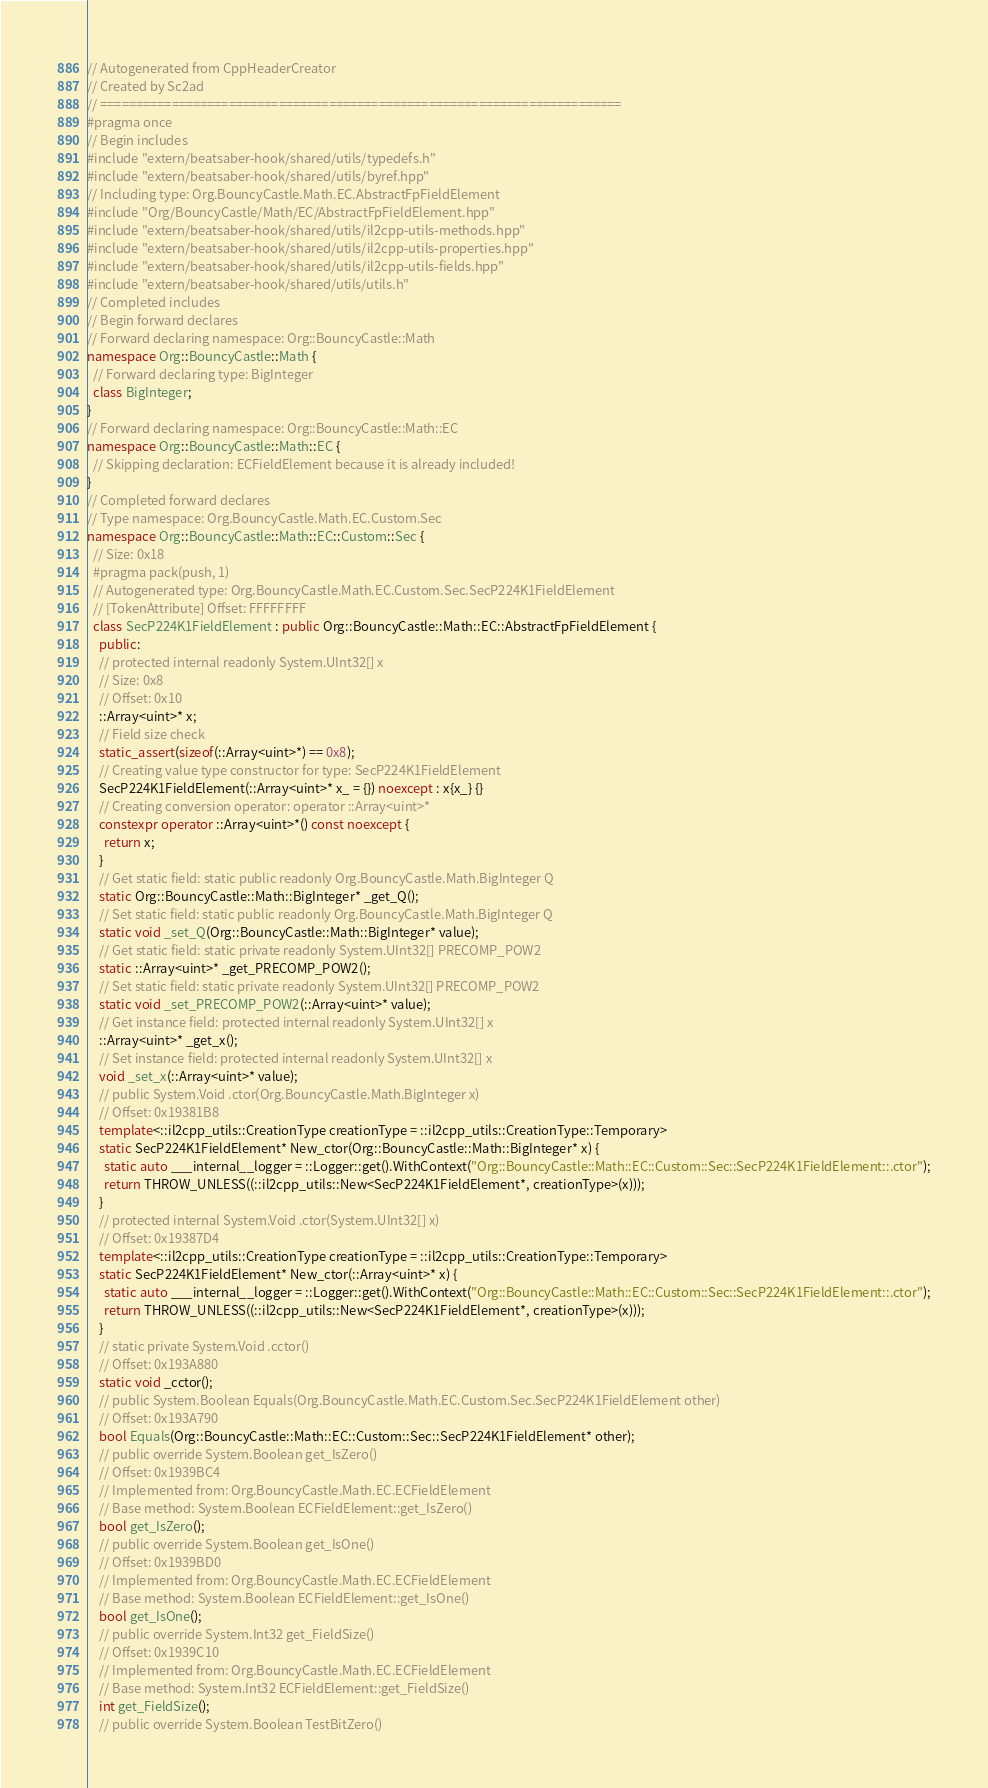<code> <loc_0><loc_0><loc_500><loc_500><_C++_>// Autogenerated from CppHeaderCreator
// Created by Sc2ad
// =========================================================================
#pragma once
// Begin includes
#include "extern/beatsaber-hook/shared/utils/typedefs.h"
#include "extern/beatsaber-hook/shared/utils/byref.hpp"
// Including type: Org.BouncyCastle.Math.EC.AbstractFpFieldElement
#include "Org/BouncyCastle/Math/EC/AbstractFpFieldElement.hpp"
#include "extern/beatsaber-hook/shared/utils/il2cpp-utils-methods.hpp"
#include "extern/beatsaber-hook/shared/utils/il2cpp-utils-properties.hpp"
#include "extern/beatsaber-hook/shared/utils/il2cpp-utils-fields.hpp"
#include "extern/beatsaber-hook/shared/utils/utils.h"
// Completed includes
// Begin forward declares
// Forward declaring namespace: Org::BouncyCastle::Math
namespace Org::BouncyCastle::Math {
  // Forward declaring type: BigInteger
  class BigInteger;
}
// Forward declaring namespace: Org::BouncyCastle::Math::EC
namespace Org::BouncyCastle::Math::EC {
  // Skipping declaration: ECFieldElement because it is already included!
}
// Completed forward declares
// Type namespace: Org.BouncyCastle.Math.EC.Custom.Sec
namespace Org::BouncyCastle::Math::EC::Custom::Sec {
  // Size: 0x18
  #pragma pack(push, 1)
  // Autogenerated type: Org.BouncyCastle.Math.EC.Custom.Sec.SecP224K1FieldElement
  // [TokenAttribute] Offset: FFFFFFFF
  class SecP224K1FieldElement : public Org::BouncyCastle::Math::EC::AbstractFpFieldElement {
    public:
    // protected internal readonly System.UInt32[] x
    // Size: 0x8
    // Offset: 0x10
    ::Array<uint>* x;
    // Field size check
    static_assert(sizeof(::Array<uint>*) == 0x8);
    // Creating value type constructor for type: SecP224K1FieldElement
    SecP224K1FieldElement(::Array<uint>* x_ = {}) noexcept : x{x_} {}
    // Creating conversion operator: operator ::Array<uint>*
    constexpr operator ::Array<uint>*() const noexcept {
      return x;
    }
    // Get static field: static public readonly Org.BouncyCastle.Math.BigInteger Q
    static Org::BouncyCastle::Math::BigInteger* _get_Q();
    // Set static field: static public readonly Org.BouncyCastle.Math.BigInteger Q
    static void _set_Q(Org::BouncyCastle::Math::BigInteger* value);
    // Get static field: static private readonly System.UInt32[] PRECOMP_POW2
    static ::Array<uint>* _get_PRECOMP_POW2();
    // Set static field: static private readonly System.UInt32[] PRECOMP_POW2
    static void _set_PRECOMP_POW2(::Array<uint>* value);
    // Get instance field: protected internal readonly System.UInt32[] x
    ::Array<uint>* _get_x();
    // Set instance field: protected internal readonly System.UInt32[] x
    void _set_x(::Array<uint>* value);
    // public System.Void .ctor(Org.BouncyCastle.Math.BigInteger x)
    // Offset: 0x19381B8
    template<::il2cpp_utils::CreationType creationType = ::il2cpp_utils::CreationType::Temporary>
    static SecP224K1FieldElement* New_ctor(Org::BouncyCastle::Math::BigInteger* x) {
      static auto ___internal__logger = ::Logger::get().WithContext("Org::BouncyCastle::Math::EC::Custom::Sec::SecP224K1FieldElement::.ctor");
      return THROW_UNLESS((::il2cpp_utils::New<SecP224K1FieldElement*, creationType>(x)));
    }
    // protected internal System.Void .ctor(System.UInt32[] x)
    // Offset: 0x19387D4
    template<::il2cpp_utils::CreationType creationType = ::il2cpp_utils::CreationType::Temporary>
    static SecP224K1FieldElement* New_ctor(::Array<uint>* x) {
      static auto ___internal__logger = ::Logger::get().WithContext("Org::BouncyCastle::Math::EC::Custom::Sec::SecP224K1FieldElement::.ctor");
      return THROW_UNLESS((::il2cpp_utils::New<SecP224K1FieldElement*, creationType>(x)));
    }
    // static private System.Void .cctor()
    // Offset: 0x193A880
    static void _cctor();
    // public System.Boolean Equals(Org.BouncyCastle.Math.EC.Custom.Sec.SecP224K1FieldElement other)
    // Offset: 0x193A790
    bool Equals(Org::BouncyCastle::Math::EC::Custom::Sec::SecP224K1FieldElement* other);
    // public override System.Boolean get_IsZero()
    // Offset: 0x1939BC4
    // Implemented from: Org.BouncyCastle.Math.EC.ECFieldElement
    // Base method: System.Boolean ECFieldElement::get_IsZero()
    bool get_IsZero();
    // public override System.Boolean get_IsOne()
    // Offset: 0x1939BD0
    // Implemented from: Org.BouncyCastle.Math.EC.ECFieldElement
    // Base method: System.Boolean ECFieldElement::get_IsOne()
    bool get_IsOne();
    // public override System.Int32 get_FieldSize()
    // Offset: 0x1939C10
    // Implemented from: Org.BouncyCastle.Math.EC.ECFieldElement
    // Base method: System.Int32 ECFieldElement::get_FieldSize()
    int get_FieldSize();
    // public override System.Boolean TestBitZero()</code> 